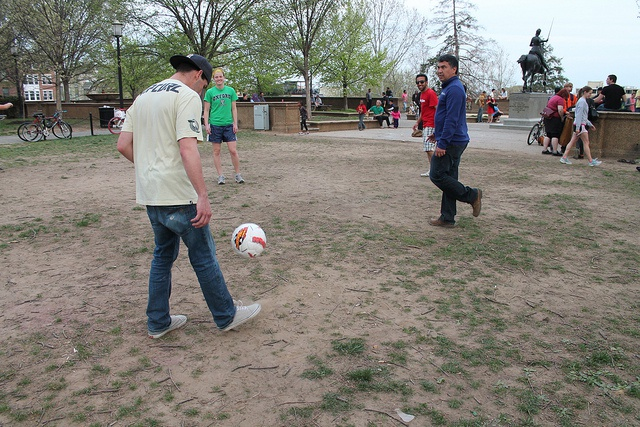Describe the objects in this image and their specific colors. I can see people in black, darkgray, lightgray, and navy tones, people in black, navy, gray, and brown tones, people in black, gray, and darkgray tones, people in black, green, darkgray, gray, and navy tones, and people in black, maroon, gray, and darkgray tones in this image. 